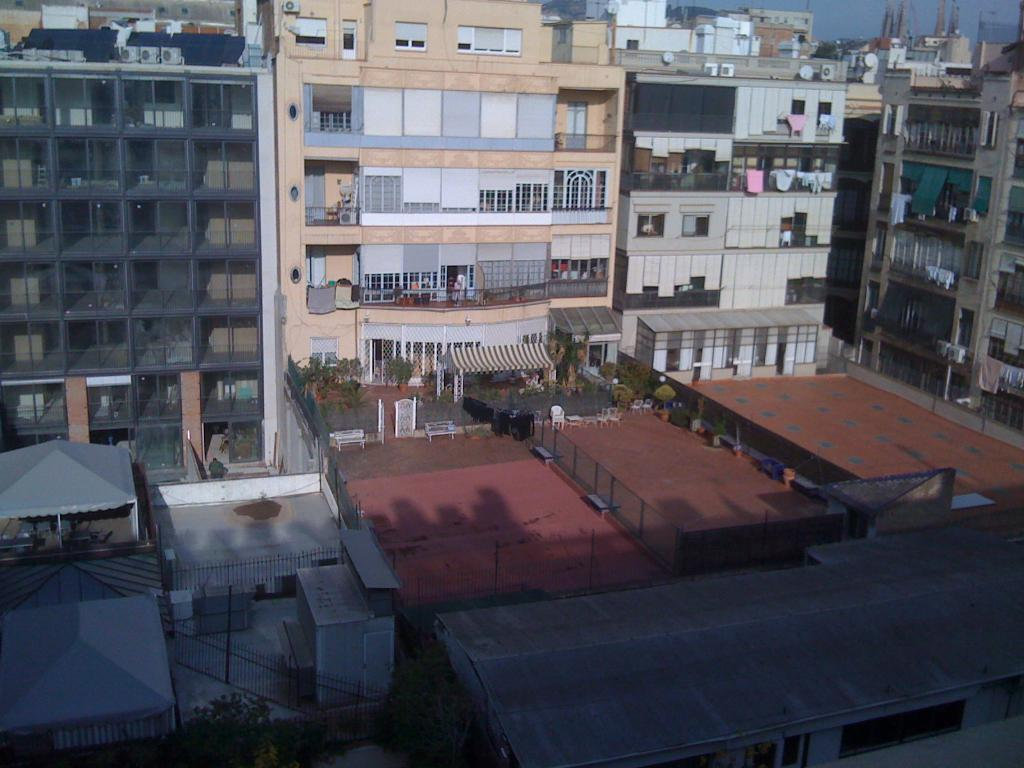What type of structures can be seen in the image? There are buildings in the image. What feature is present on top of the buildings? There are roofs in the image. What type of barrier is present in the image? There is a fence in the image. What vertical structures are present in the image? There are poles in the image. What type of vegetation is present in the image? There are trees in the image. What type of personal items are visible in the image? Clothes are visible in the image. What other objects can be seen in the image? There are other objects in the image. What can be seen in the background of the image? The sky is visible in the background of the image. Can you tell me how many clams are sitting on the roofs in the image? There are no clams present in the image; it features buildings, roofs, a fence, poles, trees, clothes, and other objects. How does the interest rate affect the buildings in the image? The image does not depict any financial information or interest rates; it is a visual representation of structures, vegetation, and objects. 